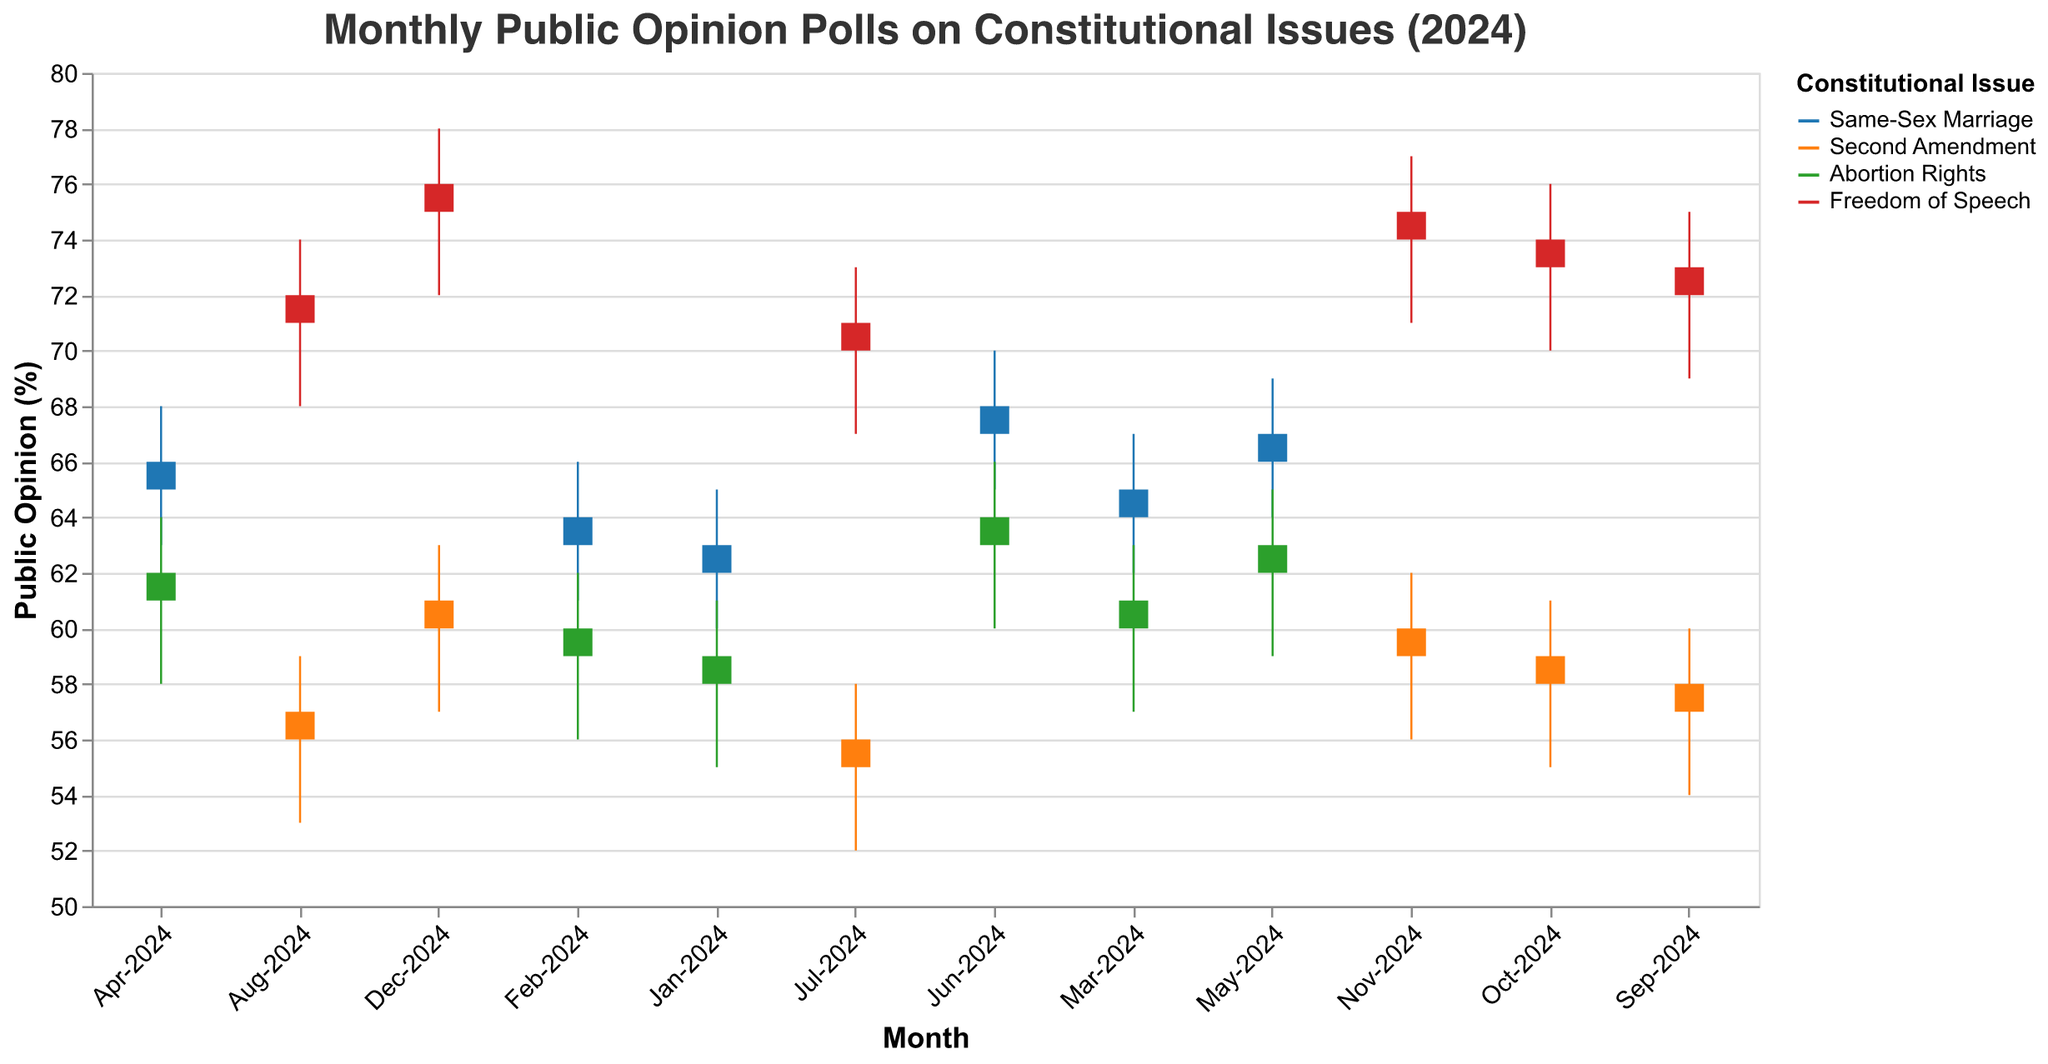What's the highest public opinion percentage for Same-Sex Marriage in 2024? To find the highest public opinion percentage for Same-Sex Marriage, look at the "High" values for each month where the issue is Same-Sex Marriage. The highest value among them is 70.
Answer: 70 What month did Abortion Rights reach a closing public opinion of 64%? To determine the month when Abortion Rights reached a closing public opinion of 64%, find the month where the "Close" value for Abortion Rights is 64. This occurs in June-2024.
Answer: June-2024 Did the Freedom of Speech issue ever have a public opinion close below 70% in 2024? To verify if the Freedom of Speech issue had a public opinion close below 70%, look at the "Close" values for the Freedom of Speech issue. The lowest closing percentage is 71 in July-2024.
Answer: No What is the total increase in the closing public opinion of Second Amendment from July-2024 to December-2024? To calculate the total increase in the closing public opinion of Second Amendment, subtract the closing percentage in July (56) from the closing percentage in December (61). The increase is 5%.
Answer: 5% Which issue shows the most stable public opinion trend in terms of monthly closing values over the year? To determine the most stable public opinion trend, look at the month-over-month changes in the "Close" values for each issue. Freedom of Speech consistently increases by 1% each month, indicating the most stable trend.
Answer: Freedom of Speech In which month did Same-Sex Marriage have its lowest public opinion low value in 2024? To find the month when Same-Sex Marriage had its lowest low value, check the "Low" values for Same-Sex Marriage in each month. The lowest value is 60 in January-2024.
Answer: January-2024 How many months did the Abortion Rights issue have a closing value above 60%? To determine the number of months Abortion Rights had a closing value above 60%, count the months where the "Close" value is greater than 60. These months are April, May, and June, making it 3 months.
Answer: 3 Compare the opening public opinion percentages of Same-Sex Marriage in January and June 2024. Which month has the higher value? To compare the opening public opinion percentages of Same-Sex Marriage, look at the "Open" values for January (62) and June (67). June has the higher value.
Answer: June What is the biggest monthly public opinion high value for the Second Amendment issue in 2024? To find the biggest monthly public opinion high value for the Second Amendment issue, check the "High" values in each month for the Second Amendment. The highest value is 63 in December-2024.
Answer: 63 